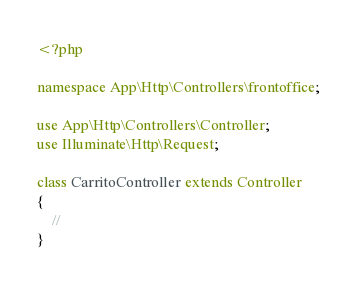<code> <loc_0><loc_0><loc_500><loc_500><_PHP_><?php

namespace App\Http\Controllers\frontoffice;

use App\Http\Controllers\Controller;
use Illuminate\Http\Request;

class CarritoController extends Controller
{
    //
}
</code> 